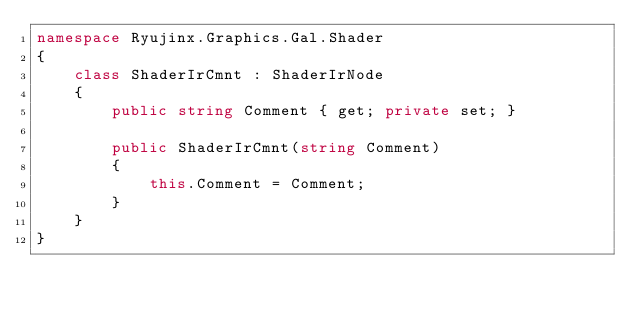Convert code to text. <code><loc_0><loc_0><loc_500><loc_500><_C#_>namespace Ryujinx.Graphics.Gal.Shader
{
    class ShaderIrCmnt : ShaderIrNode
    {
        public string Comment { get; private set; }

        public ShaderIrCmnt(string Comment)
        {
            this.Comment = Comment;
        }
    }
}</code> 